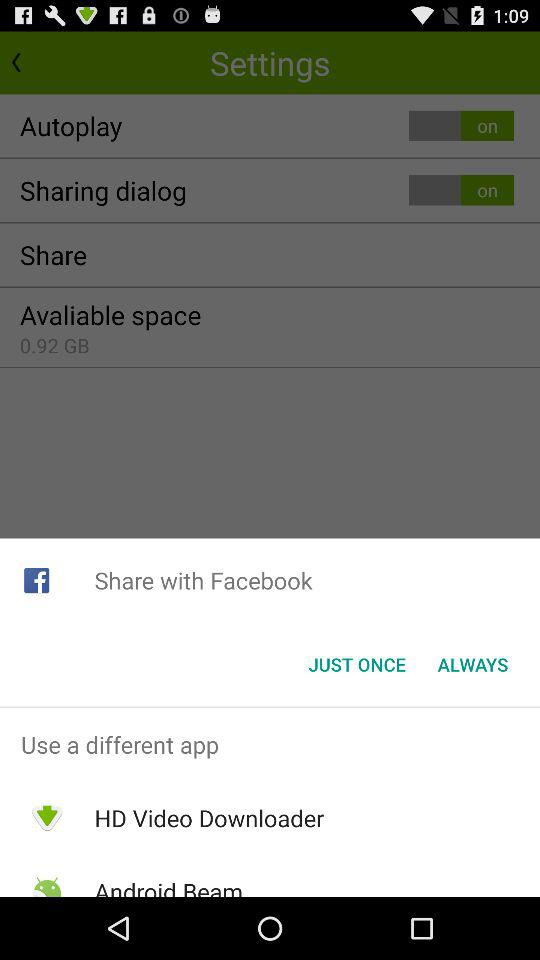How much is the "Available space" shown? The "Available space" shown is 0.92 GB. 